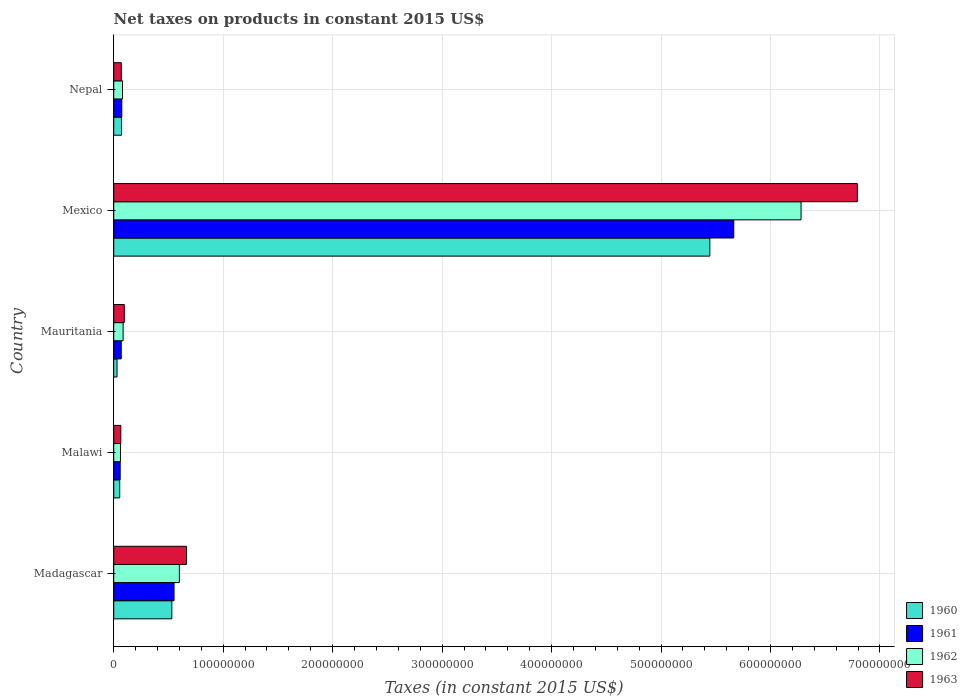How many different coloured bars are there?
Ensure brevity in your answer.  4. What is the label of the 1st group of bars from the top?
Offer a very short reply. Nepal. In how many cases, is the number of bars for a given country not equal to the number of legend labels?
Keep it short and to the point. 0. What is the net taxes on products in 1962 in Mexico?
Your answer should be compact. 6.28e+08. Across all countries, what is the maximum net taxes on products in 1960?
Your answer should be compact. 5.45e+08. Across all countries, what is the minimum net taxes on products in 1961?
Your response must be concise. 5.88e+06. In which country was the net taxes on products in 1960 maximum?
Your answer should be very brief. Mexico. In which country was the net taxes on products in 1961 minimum?
Keep it short and to the point. Malawi. What is the total net taxes on products in 1962 in the graph?
Ensure brevity in your answer.  7.11e+08. What is the difference between the net taxes on products in 1961 in Mauritania and that in Nepal?
Give a very brief answer. -5.03e+05. What is the difference between the net taxes on products in 1960 in Nepal and the net taxes on products in 1962 in Madagascar?
Provide a short and direct response. -5.29e+07. What is the average net taxes on products in 1962 per country?
Provide a succinct answer. 1.42e+08. What is the difference between the net taxes on products in 1962 and net taxes on products in 1960 in Nepal?
Ensure brevity in your answer.  9.19e+05. In how many countries, is the net taxes on products in 1962 greater than 300000000 US$?
Your response must be concise. 1. What is the ratio of the net taxes on products in 1961 in Mauritania to that in Nepal?
Ensure brevity in your answer.  0.93. Is the net taxes on products in 1961 in Malawi less than that in Nepal?
Provide a short and direct response. Yes. What is the difference between the highest and the second highest net taxes on products in 1960?
Provide a short and direct response. 4.91e+08. What is the difference between the highest and the lowest net taxes on products in 1962?
Offer a terse response. 6.22e+08. What does the 4th bar from the top in Mexico represents?
Provide a succinct answer. 1960. What is the difference between two consecutive major ticks on the X-axis?
Keep it short and to the point. 1.00e+08. Where does the legend appear in the graph?
Your response must be concise. Bottom right. How many legend labels are there?
Give a very brief answer. 4. What is the title of the graph?
Give a very brief answer. Net taxes on products in constant 2015 US$. Does "2003" appear as one of the legend labels in the graph?
Offer a very short reply. No. What is the label or title of the X-axis?
Your response must be concise. Taxes (in constant 2015 US$). What is the Taxes (in constant 2015 US$) of 1960 in Madagascar?
Make the answer very short. 5.31e+07. What is the Taxes (in constant 2015 US$) of 1961 in Madagascar?
Offer a terse response. 5.51e+07. What is the Taxes (in constant 2015 US$) of 1962 in Madagascar?
Offer a very short reply. 6.00e+07. What is the Taxes (in constant 2015 US$) of 1963 in Madagascar?
Your response must be concise. 6.64e+07. What is the Taxes (in constant 2015 US$) of 1960 in Malawi?
Make the answer very short. 5.46e+06. What is the Taxes (in constant 2015 US$) in 1961 in Malawi?
Ensure brevity in your answer.  5.88e+06. What is the Taxes (in constant 2015 US$) of 1962 in Malawi?
Offer a terse response. 6.16e+06. What is the Taxes (in constant 2015 US$) of 1963 in Malawi?
Give a very brief answer. 6.44e+06. What is the Taxes (in constant 2015 US$) of 1960 in Mauritania?
Offer a terse response. 3.00e+06. What is the Taxes (in constant 2015 US$) of 1961 in Mauritania?
Keep it short and to the point. 6.85e+06. What is the Taxes (in constant 2015 US$) of 1962 in Mauritania?
Offer a very short reply. 8.56e+06. What is the Taxes (in constant 2015 US$) of 1963 in Mauritania?
Your answer should be very brief. 9.63e+06. What is the Taxes (in constant 2015 US$) of 1960 in Mexico?
Your answer should be compact. 5.45e+08. What is the Taxes (in constant 2015 US$) of 1961 in Mexico?
Offer a terse response. 5.66e+08. What is the Taxes (in constant 2015 US$) in 1962 in Mexico?
Provide a succinct answer. 6.28e+08. What is the Taxes (in constant 2015 US$) of 1963 in Mexico?
Offer a very short reply. 6.79e+08. What is the Taxes (in constant 2015 US$) in 1960 in Nepal?
Your response must be concise. 7.09e+06. What is the Taxes (in constant 2015 US$) of 1961 in Nepal?
Your answer should be very brief. 7.35e+06. What is the Taxes (in constant 2015 US$) of 1962 in Nepal?
Your answer should be compact. 8.01e+06. What is the Taxes (in constant 2015 US$) of 1963 in Nepal?
Ensure brevity in your answer.  6.89e+06. Across all countries, what is the maximum Taxes (in constant 2015 US$) of 1960?
Your answer should be compact. 5.45e+08. Across all countries, what is the maximum Taxes (in constant 2015 US$) in 1961?
Provide a short and direct response. 5.66e+08. Across all countries, what is the maximum Taxes (in constant 2015 US$) of 1962?
Ensure brevity in your answer.  6.28e+08. Across all countries, what is the maximum Taxes (in constant 2015 US$) of 1963?
Your response must be concise. 6.79e+08. Across all countries, what is the minimum Taxes (in constant 2015 US$) of 1960?
Keep it short and to the point. 3.00e+06. Across all countries, what is the minimum Taxes (in constant 2015 US$) in 1961?
Give a very brief answer. 5.88e+06. Across all countries, what is the minimum Taxes (in constant 2015 US$) of 1962?
Keep it short and to the point. 6.16e+06. Across all countries, what is the minimum Taxes (in constant 2015 US$) of 1963?
Your answer should be compact. 6.44e+06. What is the total Taxes (in constant 2015 US$) of 1960 in the graph?
Offer a terse response. 6.13e+08. What is the total Taxes (in constant 2015 US$) in 1961 in the graph?
Your answer should be very brief. 6.42e+08. What is the total Taxes (in constant 2015 US$) in 1962 in the graph?
Keep it short and to the point. 7.11e+08. What is the total Taxes (in constant 2015 US$) in 1963 in the graph?
Your answer should be very brief. 7.69e+08. What is the difference between the Taxes (in constant 2015 US$) in 1960 in Madagascar and that in Malawi?
Provide a succinct answer. 4.76e+07. What is the difference between the Taxes (in constant 2015 US$) in 1961 in Madagascar and that in Malawi?
Make the answer very short. 4.92e+07. What is the difference between the Taxes (in constant 2015 US$) of 1962 in Madagascar and that in Malawi?
Your answer should be very brief. 5.38e+07. What is the difference between the Taxes (in constant 2015 US$) in 1963 in Madagascar and that in Malawi?
Ensure brevity in your answer.  6.00e+07. What is the difference between the Taxes (in constant 2015 US$) in 1960 in Madagascar and that in Mauritania?
Your answer should be compact. 5.01e+07. What is the difference between the Taxes (in constant 2015 US$) in 1961 in Madagascar and that in Mauritania?
Your response must be concise. 4.82e+07. What is the difference between the Taxes (in constant 2015 US$) of 1962 in Madagascar and that in Mauritania?
Offer a terse response. 5.14e+07. What is the difference between the Taxes (in constant 2015 US$) in 1963 in Madagascar and that in Mauritania?
Your response must be concise. 5.68e+07. What is the difference between the Taxes (in constant 2015 US$) in 1960 in Madagascar and that in Mexico?
Provide a succinct answer. -4.91e+08. What is the difference between the Taxes (in constant 2015 US$) of 1961 in Madagascar and that in Mexico?
Ensure brevity in your answer.  -5.11e+08. What is the difference between the Taxes (in constant 2015 US$) in 1962 in Madagascar and that in Mexico?
Make the answer very short. -5.68e+08. What is the difference between the Taxes (in constant 2015 US$) of 1963 in Madagascar and that in Mexico?
Your answer should be very brief. -6.13e+08. What is the difference between the Taxes (in constant 2015 US$) of 1960 in Madagascar and that in Nepal?
Provide a short and direct response. 4.60e+07. What is the difference between the Taxes (in constant 2015 US$) of 1961 in Madagascar and that in Nepal?
Provide a short and direct response. 4.77e+07. What is the difference between the Taxes (in constant 2015 US$) in 1962 in Madagascar and that in Nepal?
Give a very brief answer. 5.19e+07. What is the difference between the Taxes (in constant 2015 US$) in 1963 in Madagascar and that in Nepal?
Your response must be concise. 5.95e+07. What is the difference between the Taxes (in constant 2015 US$) of 1960 in Malawi and that in Mauritania?
Your answer should be very brief. 2.46e+06. What is the difference between the Taxes (in constant 2015 US$) in 1961 in Malawi and that in Mauritania?
Offer a terse response. -9.67e+05. What is the difference between the Taxes (in constant 2015 US$) of 1962 in Malawi and that in Mauritania?
Your answer should be very brief. -2.40e+06. What is the difference between the Taxes (in constant 2015 US$) in 1963 in Malawi and that in Mauritania?
Give a very brief answer. -3.19e+06. What is the difference between the Taxes (in constant 2015 US$) of 1960 in Malawi and that in Mexico?
Your response must be concise. -5.39e+08. What is the difference between the Taxes (in constant 2015 US$) of 1961 in Malawi and that in Mexico?
Offer a terse response. -5.61e+08. What is the difference between the Taxes (in constant 2015 US$) in 1962 in Malawi and that in Mexico?
Provide a short and direct response. -6.22e+08. What is the difference between the Taxes (in constant 2015 US$) in 1963 in Malawi and that in Mexico?
Your response must be concise. -6.73e+08. What is the difference between the Taxes (in constant 2015 US$) in 1960 in Malawi and that in Nepal?
Your answer should be compact. -1.63e+06. What is the difference between the Taxes (in constant 2015 US$) of 1961 in Malawi and that in Nepal?
Your answer should be very brief. -1.47e+06. What is the difference between the Taxes (in constant 2015 US$) in 1962 in Malawi and that in Nepal?
Offer a terse response. -1.85e+06. What is the difference between the Taxes (in constant 2015 US$) in 1963 in Malawi and that in Nepal?
Provide a succinct answer. -4.50e+05. What is the difference between the Taxes (in constant 2015 US$) of 1960 in Mauritania and that in Mexico?
Give a very brief answer. -5.42e+08. What is the difference between the Taxes (in constant 2015 US$) of 1961 in Mauritania and that in Mexico?
Keep it short and to the point. -5.60e+08. What is the difference between the Taxes (in constant 2015 US$) in 1962 in Mauritania and that in Mexico?
Offer a very short reply. -6.19e+08. What is the difference between the Taxes (in constant 2015 US$) in 1963 in Mauritania and that in Mexico?
Your response must be concise. -6.70e+08. What is the difference between the Taxes (in constant 2015 US$) in 1960 in Mauritania and that in Nepal?
Make the answer very short. -4.09e+06. What is the difference between the Taxes (in constant 2015 US$) in 1961 in Mauritania and that in Nepal?
Your response must be concise. -5.03e+05. What is the difference between the Taxes (in constant 2015 US$) in 1962 in Mauritania and that in Nepal?
Your answer should be very brief. 5.53e+05. What is the difference between the Taxes (in constant 2015 US$) of 1963 in Mauritania and that in Nepal?
Your answer should be compact. 2.74e+06. What is the difference between the Taxes (in constant 2015 US$) in 1960 in Mexico and that in Nepal?
Offer a very short reply. 5.37e+08. What is the difference between the Taxes (in constant 2015 US$) in 1961 in Mexico and that in Nepal?
Keep it short and to the point. 5.59e+08. What is the difference between the Taxes (in constant 2015 US$) in 1962 in Mexico and that in Nepal?
Keep it short and to the point. 6.20e+08. What is the difference between the Taxes (in constant 2015 US$) in 1963 in Mexico and that in Nepal?
Keep it short and to the point. 6.72e+08. What is the difference between the Taxes (in constant 2015 US$) of 1960 in Madagascar and the Taxes (in constant 2015 US$) of 1961 in Malawi?
Offer a very short reply. 4.72e+07. What is the difference between the Taxes (in constant 2015 US$) of 1960 in Madagascar and the Taxes (in constant 2015 US$) of 1962 in Malawi?
Ensure brevity in your answer.  4.69e+07. What is the difference between the Taxes (in constant 2015 US$) of 1960 in Madagascar and the Taxes (in constant 2015 US$) of 1963 in Malawi?
Your answer should be very brief. 4.66e+07. What is the difference between the Taxes (in constant 2015 US$) in 1961 in Madagascar and the Taxes (in constant 2015 US$) in 1962 in Malawi?
Offer a terse response. 4.89e+07. What is the difference between the Taxes (in constant 2015 US$) of 1961 in Madagascar and the Taxes (in constant 2015 US$) of 1963 in Malawi?
Offer a very short reply. 4.87e+07. What is the difference between the Taxes (in constant 2015 US$) of 1962 in Madagascar and the Taxes (in constant 2015 US$) of 1963 in Malawi?
Your answer should be compact. 5.35e+07. What is the difference between the Taxes (in constant 2015 US$) of 1960 in Madagascar and the Taxes (in constant 2015 US$) of 1961 in Mauritania?
Provide a succinct answer. 4.62e+07. What is the difference between the Taxes (in constant 2015 US$) in 1960 in Madagascar and the Taxes (in constant 2015 US$) in 1962 in Mauritania?
Provide a succinct answer. 4.45e+07. What is the difference between the Taxes (in constant 2015 US$) of 1960 in Madagascar and the Taxes (in constant 2015 US$) of 1963 in Mauritania?
Give a very brief answer. 4.34e+07. What is the difference between the Taxes (in constant 2015 US$) in 1961 in Madagascar and the Taxes (in constant 2015 US$) in 1962 in Mauritania?
Your response must be concise. 4.65e+07. What is the difference between the Taxes (in constant 2015 US$) in 1961 in Madagascar and the Taxes (in constant 2015 US$) in 1963 in Mauritania?
Give a very brief answer. 4.55e+07. What is the difference between the Taxes (in constant 2015 US$) in 1962 in Madagascar and the Taxes (in constant 2015 US$) in 1963 in Mauritania?
Keep it short and to the point. 5.03e+07. What is the difference between the Taxes (in constant 2015 US$) in 1960 in Madagascar and the Taxes (in constant 2015 US$) in 1961 in Mexico?
Offer a very short reply. -5.13e+08. What is the difference between the Taxes (in constant 2015 US$) of 1960 in Madagascar and the Taxes (in constant 2015 US$) of 1962 in Mexico?
Ensure brevity in your answer.  -5.75e+08. What is the difference between the Taxes (in constant 2015 US$) in 1960 in Madagascar and the Taxes (in constant 2015 US$) in 1963 in Mexico?
Give a very brief answer. -6.26e+08. What is the difference between the Taxes (in constant 2015 US$) in 1961 in Madagascar and the Taxes (in constant 2015 US$) in 1962 in Mexico?
Provide a short and direct response. -5.73e+08. What is the difference between the Taxes (in constant 2015 US$) of 1961 in Madagascar and the Taxes (in constant 2015 US$) of 1963 in Mexico?
Provide a short and direct response. -6.24e+08. What is the difference between the Taxes (in constant 2015 US$) in 1962 in Madagascar and the Taxes (in constant 2015 US$) in 1963 in Mexico?
Keep it short and to the point. -6.19e+08. What is the difference between the Taxes (in constant 2015 US$) of 1960 in Madagascar and the Taxes (in constant 2015 US$) of 1961 in Nepal?
Ensure brevity in your answer.  4.57e+07. What is the difference between the Taxes (in constant 2015 US$) in 1960 in Madagascar and the Taxes (in constant 2015 US$) in 1962 in Nepal?
Your answer should be very brief. 4.51e+07. What is the difference between the Taxes (in constant 2015 US$) in 1960 in Madagascar and the Taxes (in constant 2015 US$) in 1963 in Nepal?
Offer a very short reply. 4.62e+07. What is the difference between the Taxes (in constant 2015 US$) in 1961 in Madagascar and the Taxes (in constant 2015 US$) in 1962 in Nepal?
Your answer should be compact. 4.71e+07. What is the difference between the Taxes (in constant 2015 US$) of 1961 in Madagascar and the Taxes (in constant 2015 US$) of 1963 in Nepal?
Your answer should be compact. 4.82e+07. What is the difference between the Taxes (in constant 2015 US$) in 1962 in Madagascar and the Taxes (in constant 2015 US$) in 1963 in Nepal?
Your response must be concise. 5.31e+07. What is the difference between the Taxes (in constant 2015 US$) in 1960 in Malawi and the Taxes (in constant 2015 US$) in 1961 in Mauritania?
Your answer should be compact. -1.39e+06. What is the difference between the Taxes (in constant 2015 US$) of 1960 in Malawi and the Taxes (in constant 2015 US$) of 1962 in Mauritania?
Provide a short and direct response. -3.10e+06. What is the difference between the Taxes (in constant 2015 US$) of 1960 in Malawi and the Taxes (in constant 2015 US$) of 1963 in Mauritania?
Your answer should be compact. -4.17e+06. What is the difference between the Taxes (in constant 2015 US$) in 1961 in Malawi and the Taxes (in constant 2015 US$) in 1962 in Mauritania?
Provide a short and direct response. -2.68e+06. What is the difference between the Taxes (in constant 2015 US$) of 1961 in Malawi and the Taxes (in constant 2015 US$) of 1963 in Mauritania?
Ensure brevity in your answer.  -3.75e+06. What is the difference between the Taxes (in constant 2015 US$) in 1962 in Malawi and the Taxes (in constant 2015 US$) in 1963 in Mauritania?
Give a very brief answer. -3.47e+06. What is the difference between the Taxes (in constant 2015 US$) of 1960 in Malawi and the Taxes (in constant 2015 US$) of 1961 in Mexico?
Provide a succinct answer. -5.61e+08. What is the difference between the Taxes (in constant 2015 US$) in 1960 in Malawi and the Taxes (in constant 2015 US$) in 1962 in Mexico?
Ensure brevity in your answer.  -6.22e+08. What is the difference between the Taxes (in constant 2015 US$) in 1960 in Malawi and the Taxes (in constant 2015 US$) in 1963 in Mexico?
Provide a short and direct response. -6.74e+08. What is the difference between the Taxes (in constant 2015 US$) in 1961 in Malawi and the Taxes (in constant 2015 US$) in 1962 in Mexico?
Keep it short and to the point. -6.22e+08. What is the difference between the Taxes (in constant 2015 US$) of 1961 in Malawi and the Taxes (in constant 2015 US$) of 1963 in Mexico?
Your response must be concise. -6.73e+08. What is the difference between the Taxes (in constant 2015 US$) in 1962 in Malawi and the Taxes (in constant 2015 US$) in 1963 in Mexico?
Keep it short and to the point. -6.73e+08. What is the difference between the Taxes (in constant 2015 US$) in 1960 in Malawi and the Taxes (in constant 2015 US$) in 1961 in Nepal?
Make the answer very short. -1.89e+06. What is the difference between the Taxes (in constant 2015 US$) in 1960 in Malawi and the Taxes (in constant 2015 US$) in 1962 in Nepal?
Your response must be concise. -2.55e+06. What is the difference between the Taxes (in constant 2015 US$) in 1960 in Malawi and the Taxes (in constant 2015 US$) in 1963 in Nepal?
Keep it short and to the point. -1.43e+06. What is the difference between the Taxes (in constant 2015 US$) in 1961 in Malawi and the Taxes (in constant 2015 US$) in 1962 in Nepal?
Offer a very short reply. -2.13e+06. What is the difference between the Taxes (in constant 2015 US$) in 1961 in Malawi and the Taxes (in constant 2015 US$) in 1963 in Nepal?
Your answer should be compact. -1.01e+06. What is the difference between the Taxes (in constant 2015 US$) in 1962 in Malawi and the Taxes (in constant 2015 US$) in 1963 in Nepal?
Ensure brevity in your answer.  -7.30e+05. What is the difference between the Taxes (in constant 2015 US$) in 1960 in Mauritania and the Taxes (in constant 2015 US$) in 1961 in Mexico?
Give a very brief answer. -5.63e+08. What is the difference between the Taxes (in constant 2015 US$) in 1960 in Mauritania and the Taxes (in constant 2015 US$) in 1962 in Mexico?
Keep it short and to the point. -6.25e+08. What is the difference between the Taxes (in constant 2015 US$) of 1960 in Mauritania and the Taxes (in constant 2015 US$) of 1963 in Mexico?
Ensure brevity in your answer.  -6.76e+08. What is the difference between the Taxes (in constant 2015 US$) in 1961 in Mauritania and the Taxes (in constant 2015 US$) in 1962 in Mexico?
Give a very brief answer. -6.21e+08. What is the difference between the Taxes (in constant 2015 US$) in 1961 in Mauritania and the Taxes (in constant 2015 US$) in 1963 in Mexico?
Your answer should be very brief. -6.73e+08. What is the difference between the Taxes (in constant 2015 US$) in 1962 in Mauritania and the Taxes (in constant 2015 US$) in 1963 in Mexico?
Provide a short and direct response. -6.71e+08. What is the difference between the Taxes (in constant 2015 US$) in 1960 in Mauritania and the Taxes (in constant 2015 US$) in 1961 in Nepal?
Your response must be concise. -4.35e+06. What is the difference between the Taxes (in constant 2015 US$) in 1960 in Mauritania and the Taxes (in constant 2015 US$) in 1962 in Nepal?
Give a very brief answer. -5.01e+06. What is the difference between the Taxes (in constant 2015 US$) of 1960 in Mauritania and the Taxes (in constant 2015 US$) of 1963 in Nepal?
Ensure brevity in your answer.  -3.89e+06. What is the difference between the Taxes (in constant 2015 US$) in 1961 in Mauritania and the Taxes (in constant 2015 US$) in 1962 in Nepal?
Your answer should be compact. -1.16e+06. What is the difference between the Taxes (in constant 2015 US$) of 1961 in Mauritania and the Taxes (in constant 2015 US$) of 1963 in Nepal?
Provide a short and direct response. -4.29e+04. What is the difference between the Taxes (in constant 2015 US$) of 1962 in Mauritania and the Taxes (in constant 2015 US$) of 1963 in Nepal?
Give a very brief answer. 1.67e+06. What is the difference between the Taxes (in constant 2015 US$) of 1960 in Mexico and the Taxes (in constant 2015 US$) of 1961 in Nepal?
Make the answer very short. 5.37e+08. What is the difference between the Taxes (in constant 2015 US$) in 1960 in Mexico and the Taxes (in constant 2015 US$) in 1962 in Nepal?
Your answer should be very brief. 5.37e+08. What is the difference between the Taxes (in constant 2015 US$) of 1960 in Mexico and the Taxes (in constant 2015 US$) of 1963 in Nepal?
Provide a short and direct response. 5.38e+08. What is the difference between the Taxes (in constant 2015 US$) in 1961 in Mexico and the Taxes (in constant 2015 US$) in 1962 in Nepal?
Your answer should be compact. 5.58e+08. What is the difference between the Taxes (in constant 2015 US$) of 1961 in Mexico and the Taxes (in constant 2015 US$) of 1963 in Nepal?
Your answer should be very brief. 5.60e+08. What is the difference between the Taxes (in constant 2015 US$) of 1962 in Mexico and the Taxes (in constant 2015 US$) of 1963 in Nepal?
Keep it short and to the point. 6.21e+08. What is the average Taxes (in constant 2015 US$) in 1960 per country?
Offer a terse response. 1.23e+08. What is the average Taxes (in constant 2015 US$) in 1961 per country?
Ensure brevity in your answer.  1.28e+08. What is the average Taxes (in constant 2015 US$) of 1962 per country?
Your answer should be compact. 1.42e+08. What is the average Taxes (in constant 2015 US$) of 1963 per country?
Provide a succinct answer. 1.54e+08. What is the difference between the Taxes (in constant 2015 US$) of 1960 and Taxes (in constant 2015 US$) of 1961 in Madagascar?
Your answer should be very brief. -2.03e+06. What is the difference between the Taxes (in constant 2015 US$) of 1960 and Taxes (in constant 2015 US$) of 1962 in Madagascar?
Provide a short and direct response. -6.89e+06. What is the difference between the Taxes (in constant 2015 US$) of 1960 and Taxes (in constant 2015 US$) of 1963 in Madagascar?
Keep it short and to the point. -1.34e+07. What is the difference between the Taxes (in constant 2015 US$) in 1961 and Taxes (in constant 2015 US$) in 1962 in Madagascar?
Provide a short and direct response. -4.86e+06. What is the difference between the Taxes (in constant 2015 US$) of 1961 and Taxes (in constant 2015 US$) of 1963 in Madagascar?
Keep it short and to the point. -1.13e+07. What is the difference between the Taxes (in constant 2015 US$) of 1962 and Taxes (in constant 2015 US$) of 1963 in Madagascar?
Provide a short and direct response. -6.48e+06. What is the difference between the Taxes (in constant 2015 US$) of 1960 and Taxes (in constant 2015 US$) of 1961 in Malawi?
Provide a succinct answer. -4.20e+05. What is the difference between the Taxes (in constant 2015 US$) in 1960 and Taxes (in constant 2015 US$) in 1962 in Malawi?
Ensure brevity in your answer.  -7.00e+05. What is the difference between the Taxes (in constant 2015 US$) of 1960 and Taxes (in constant 2015 US$) of 1963 in Malawi?
Provide a succinct answer. -9.80e+05. What is the difference between the Taxes (in constant 2015 US$) of 1961 and Taxes (in constant 2015 US$) of 1962 in Malawi?
Your response must be concise. -2.80e+05. What is the difference between the Taxes (in constant 2015 US$) in 1961 and Taxes (in constant 2015 US$) in 1963 in Malawi?
Provide a short and direct response. -5.60e+05. What is the difference between the Taxes (in constant 2015 US$) in 1962 and Taxes (in constant 2015 US$) in 1963 in Malawi?
Provide a succinct answer. -2.80e+05. What is the difference between the Taxes (in constant 2015 US$) in 1960 and Taxes (in constant 2015 US$) in 1961 in Mauritania?
Your answer should be compact. -3.85e+06. What is the difference between the Taxes (in constant 2015 US$) in 1960 and Taxes (in constant 2015 US$) in 1962 in Mauritania?
Your response must be concise. -5.56e+06. What is the difference between the Taxes (in constant 2015 US$) in 1960 and Taxes (in constant 2015 US$) in 1963 in Mauritania?
Your answer should be very brief. -6.63e+06. What is the difference between the Taxes (in constant 2015 US$) of 1961 and Taxes (in constant 2015 US$) of 1962 in Mauritania?
Your response must be concise. -1.71e+06. What is the difference between the Taxes (in constant 2015 US$) in 1961 and Taxes (in constant 2015 US$) in 1963 in Mauritania?
Your answer should be compact. -2.78e+06. What is the difference between the Taxes (in constant 2015 US$) in 1962 and Taxes (in constant 2015 US$) in 1963 in Mauritania?
Your answer should be very brief. -1.07e+06. What is the difference between the Taxes (in constant 2015 US$) in 1960 and Taxes (in constant 2015 US$) in 1961 in Mexico?
Ensure brevity in your answer.  -2.18e+07. What is the difference between the Taxes (in constant 2015 US$) in 1960 and Taxes (in constant 2015 US$) in 1962 in Mexico?
Ensure brevity in your answer.  -8.34e+07. What is the difference between the Taxes (in constant 2015 US$) in 1960 and Taxes (in constant 2015 US$) in 1963 in Mexico?
Offer a very short reply. -1.35e+08. What is the difference between the Taxes (in constant 2015 US$) of 1961 and Taxes (in constant 2015 US$) of 1962 in Mexico?
Provide a succinct answer. -6.15e+07. What is the difference between the Taxes (in constant 2015 US$) in 1961 and Taxes (in constant 2015 US$) in 1963 in Mexico?
Provide a short and direct response. -1.13e+08. What is the difference between the Taxes (in constant 2015 US$) in 1962 and Taxes (in constant 2015 US$) in 1963 in Mexico?
Provide a short and direct response. -5.14e+07. What is the difference between the Taxes (in constant 2015 US$) of 1960 and Taxes (in constant 2015 US$) of 1961 in Nepal?
Ensure brevity in your answer.  -2.63e+05. What is the difference between the Taxes (in constant 2015 US$) in 1960 and Taxes (in constant 2015 US$) in 1962 in Nepal?
Make the answer very short. -9.19e+05. What is the difference between the Taxes (in constant 2015 US$) in 1960 and Taxes (in constant 2015 US$) in 1963 in Nepal?
Offer a very short reply. 1.97e+05. What is the difference between the Taxes (in constant 2015 US$) in 1961 and Taxes (in constant 2015 US$) in 1962 in Nepal?
Make the answer very short. -6.56e+05. What is the difference between the Taxes (in constant 2015 US$) of 1961 and Taxes (in constant 2015 US$) of 1963 in Nepal?
Your response must be concise. 4.60e+05. What is the difference between the Taxes (in constant 2015 US$) in 1962 and Taxes (in constant 2015 US$) in 1963 in Nepal?
Provide a succinct answer. 1.12e+06. What is the ratio of the Taxes (in constant 2015 US$) of 1960 in Madagascar to that in Malawi?
Your response must be concise. 9.72. What is the ratio of the Taxes (in constant 2015 US$) in 1961 in Madagascar to that in Malawi?
Offer a very short reply. 9.37. What is the ratio of the Taxes (in constant 2015 US$) of 1962 in Madagascar to that in Malawi?
Your answer should be compact. 9.73. What is the ratio of the Taxes (in constant 2015 US$) of 1963 in Madagascar to that in Malawi?
Give a very brief answer. 10.32. What is the ratio of the Taxes (in constant 2015 US$) of 1960 in Madagascar to that in Mauritania?
Offer a terse response. 17.72. What is the ratio of the Taxes (in constant 2015 US$) in 1961 in Madagascar to that in Mauritania?
Your answer should be very brief. 8.05. What is the ratio of the Taxes (in constant 2015 US$) in 1962 in Madagascar to that in Mauritania?
Make the answer very short. 7. What is the ratio of the Taxes (in constant 2015 US$) of 1963 in Madagascar to that in Mauritania?
Your response must be concise. 6.9. What is the ratio of the Taxes (in constant 2015 US$) in 1960 in Madagascar to that in Mexico?
Make the answer very short. 0.1. What is the ratio of the Taxes (in constant 2015 US$) in 1961 in Madagascar to that in Mexico?
Your answer should be very brief. 0.1. What is the ratio of the Taxes (in constant 2015 US$) of 1962 in Madagascar to that in Mexico?
Provide a short and direct response. 0.1. What is the ratio of the Taxes (in constant 2015 US$) in 1963 in Madagascar to that in Mexico?
Provide a succinct answer. 0.1. What is the ratio of the Taxes (in constant 2015 US$) of 1960 in Madagascar to that in Nepal?
Offer a very short reply. 7.49. What is the ratio of the Taxes (in constant 2015 US$) in 1961 in Madagascar to that in Nepal?
Offer a terse response. 7.5. What is the ratio of the Taxes (in constant 2015 US$) in 1962 in Madagascar to that in Nepal?
Make the answer very short. 7.49. What is the ratio of the Taxes (in constant 2015 US$) of 1963 in Madagascar to that in Nepal?
Your answer should be compact. 9.64. What is the ratio of the Taxes (in constant 2015 US$) of 1960 in Malawi to that in Mauritania?
Give a very brief answer. 1.82. What is the ratio of the Taxes (in constant 2015 US$) in 1961 in Malawi to that in Mauritania?
Provide a succinct answer. 0.86. What is the ratio of the Taxes (in constant 2015 US$) in 1962 in Malawi to that in Mauritania?
Your answer should be very brief. 0.72. What is the ratio of the Taxes (in constant 2015 US$) in 1963 in Malawi to that in Mauritania?
Ensure brevity in your answer.  0.67. What is the ratio of the Taxes (in constant 2015 US$) in 1960 in Malawi to that in Mexico?
Your answer should be very brief. 0.01. What is the ratio of the Taxes (in constant 2015 US$) of 1961 in Malawi to that in Mexico?
Your answer should be compact. 0.01. What is the ratio of the Taxes (in constant 2015 US$) of 1962 in Malawi to that in Mexico?
Give a very brief answer. 0.01. What is the ratio of the Taxes (in constant 2015 US$) of 1963 in Malawi to that in Mexico?
Offer a terse response. 0.01. What is the ratio of the Taxes (in constant 2015 US$) of 1960 in Malawi to that in Nepal?
Ensure brevity in your answer.  0.77. What is the ratio of the Taxes (in constant 2015 US$) in 1962 in Malawi to that in Nepal?
Ensure brevity in your answer.  0.77. What is the ratio of the Taxes (in constant 2015 US$) in 1963 in Malawi to that in Nepal?
Ensure brevity in your answer.  0.93. What is the ratio of the Taxes (in constant 2015 US$) of 1960 in Mauritania to that in Mexico?
Give a very brief answer. 0.01. What is the ratio of the Taxes (in constant 2015 US$) in 1961 in Mauritania to that in Mexico?
Your answer should be very brief. 0.01. What is the ratio of the Taxes (in constant 2015 US$) in 1962 in Mauritania to that in Mexico?
Offer a terse response. 0.01. What is the ratio of the Taxes (in constant 2015 US$) in 1963 in Mauritania to that in Mexico?
Make the answer very short. 0.01. What is the ratio of the Taxes (in constant 2015 US$) in 1960 in Mauritania to that in Nepal?
Keep it short and to the point. 0.42. What is the ratio of the Taxes (in constant 2015 US$) in 1961 in Mauritania to that in Nepal?
Make the answer very short. 0.93. What is the ratio of the Taxes (in constant 2015 US$) in 1962 in Mauritania to that in Nepal?
Keep it short and to the point. 1.07. What is the ratio of the Taxes (in constant 2015 US$) of 1963 in Mauritania to that in Nepal?
Ensure brevity in your answer.  1.4. What is the ratio of the Taxes (in constant 2015 US$) of 1960 in Mexico to that in Nepal?
Offer a terse response. 76.83. What is the ratio of the Taxes (in constant 2015 US$) of 1961 in Mexico to that in Nepal?
Your answer should be compact. 77.06. What is the ratio of the Taxes (in constant 2015 US$) in 1962 in Mexico to that in Nepal?
Offer a very short reply. 78.43. What is the ratio of the Taxes (in constant 2015 US$) in 1963 in Mexico to that in Nepal?
Offer a very short reply. 98.6. What is the difference between the highest and the second highest Taxes (in constant 2015 US$) in 1960?
Make the answer very short. 4.91e+08. What is the difference between the highest and the second highest Taxes (in constant 2015 US$) of 1961?
Your answer should be very brief. 5.11e+08. What is the difference between the highest and the second highest Taxes (in constant 2015 US$) in 1962?
Your answer should be very brief. 5.68e+08. What is the difference between the highest and the second highest Taxes (in constant 2015 US$) in 1963?
Your answer should be very brief. 6.13e+08. What is the difference between the highest and the lowest Taxes (in constant 2015 US$) of 1960?
Your answer should be very brief. 5.42e+08. What is the difference between the highest and the lowest Taxes (in constant 2015 US$) in 1961?
Offer a very short reply. 5.61e+08. What is the difference between the highest and the lowest Taxes (in constant 2015 US$) in 1962?
Keep it short and to the point. 6.22e+08. What is the difference between the highest and the lowest Taxes (in constant 2015 US$) in 1963?
Provide a short and direct response. 6.73e+08. 